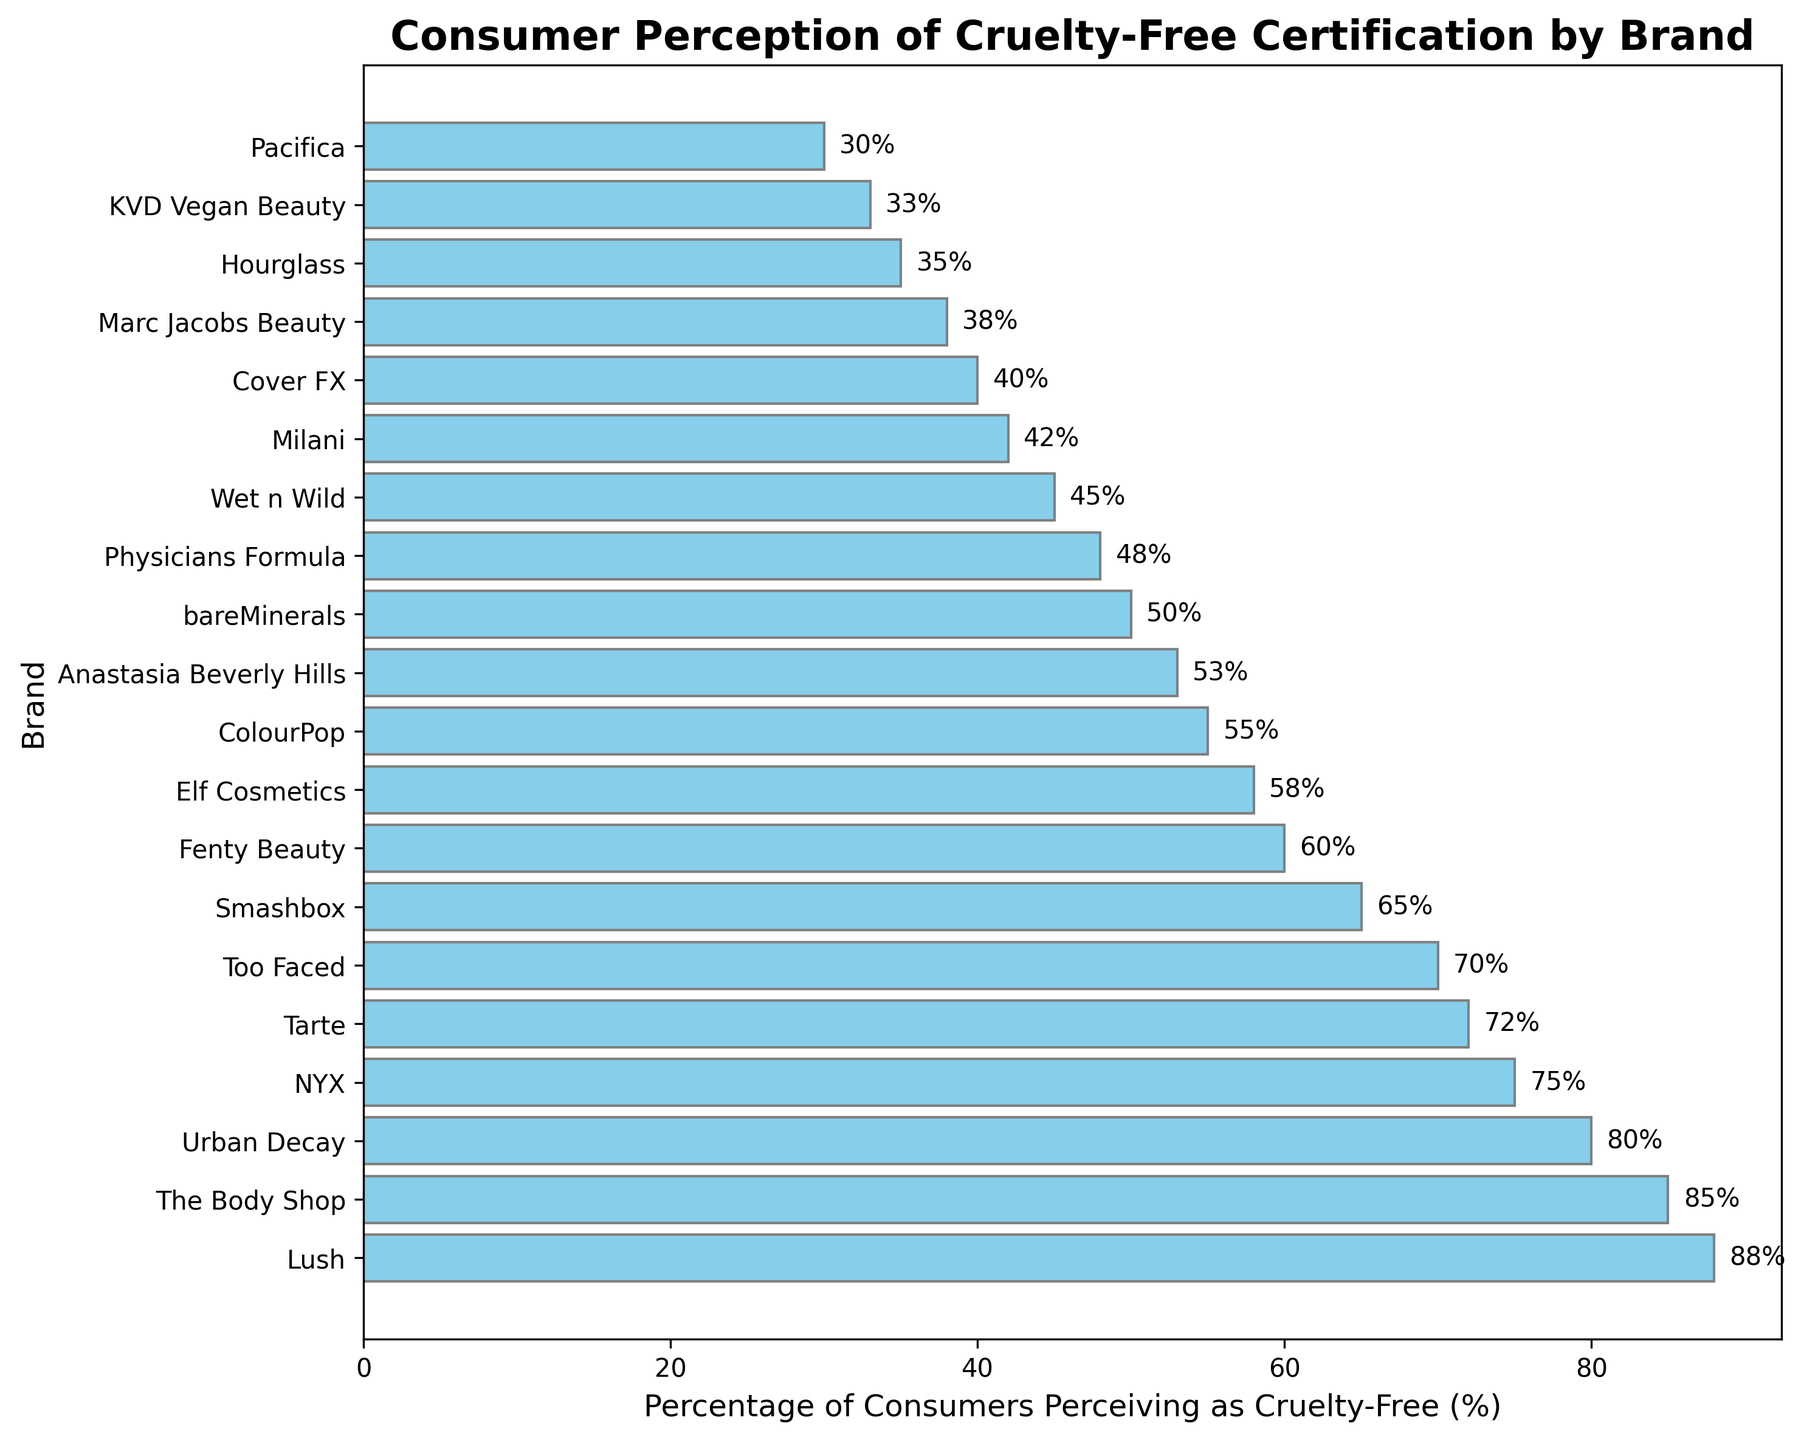Which brand has the highest percentage of consumers perceiving it as cruelty-free? The tallest bar in the chart represents "Lush" with a percentage label of "88%".
Answer: Lush Which brand has the lowest percentage of consumers perceiving it as cruelty-free? The shortest bar in the chart represents "Pacifica" with a percentage label of "30%".
Answer: Pacifica Is the percentage of consumers perceiving "Urban Decay" as cruelty-free greater than "NYX"? Comparing the lengths of the bars, "Urban Decay" has 80% while "NYX" has 75%.
Answer: Yes Between "Fenty Beauty" and "Elf Cosmetics," which brand is perceived by more consumers as cruelty-free and by how much? "Fenty Beauty" is perceived as cruelty-free by 60%, while "Elf Cosmetics" is perceived as cruelty-free by 58%. The difference is 60% - 58% = 2%.
Answer: Fenty Beauty, by 2% What is the average percentage perception of cruelty-free certification among the top 5 brands? Adding the percentages of the top 5 brands: (88 + 85 + 80 + 75 + 72) = 400. Dividing by 5 gives 400/5 = 80%.
Answer: 80% How does the perception of cruelty-free certification for "Tarte" compare to "Too Faced"? "Tarte" has a percentage of 72% while "Too Faced" has 70%.
Answer: Tarte is higher Calculate the total percentage of consumers perceiving the bottom 3 brands as cruelty-free. Adding percentages for the bottom 3 brands: "Hourglass" (35%), "KVD Vegan Beauty" (33%), and "Pacifica" (30%). The total is 35 + 33 + 30 = 98%.
Answer: 98% Which brands have a percentage perception of cruelty-free certification between 50% and 60%? The brands with percentages within this range are "bareMinerals" (50%), "Physicians Formula" (48%), "Wet n Wild" (45%), and "Milani" (42%).
Answer: bareMinerals, Physicians Formula, Wet n Wild, Milani What percentage of consumers perceive "ColourPop" as cruelty-free, and how does it compare to "Anastasia Beverly Hills"? "ColourPop" has 55%, and "Anastasia Beverly Hills" has 53%. "ColourPop" is perceived higher by 2%.
Answer: 55%, and higher than "Anastasia Beverly Hills" by 2% 